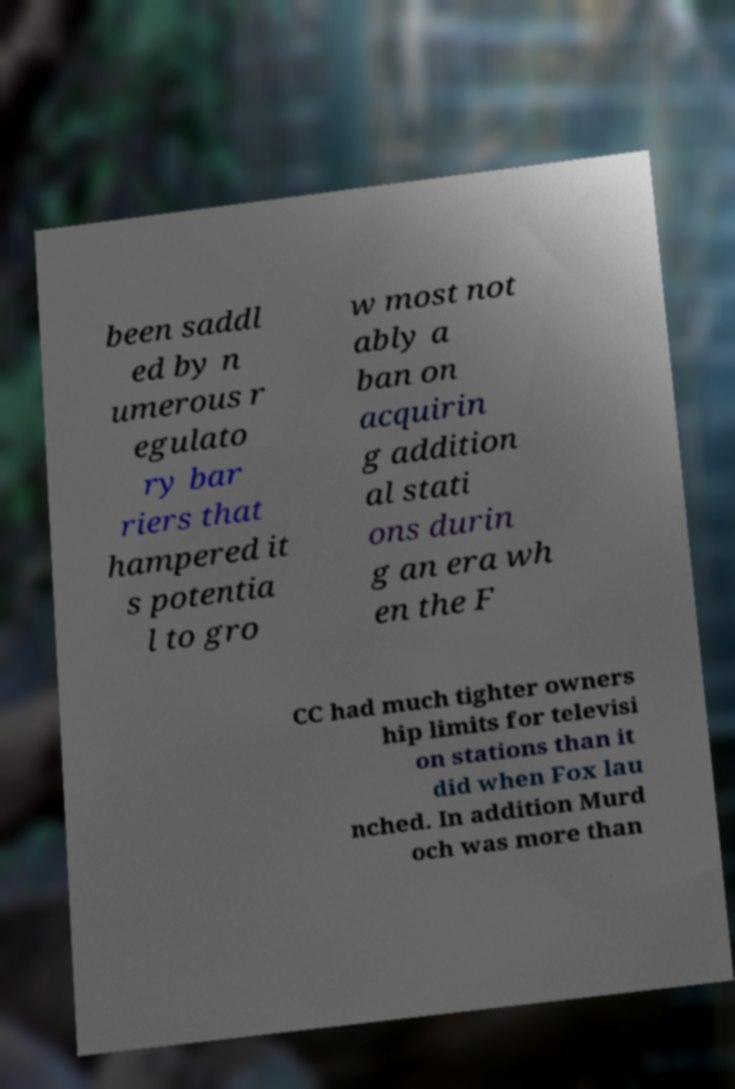What messages or text are displayed in this image? I need them in a readable, typed format. been saddl ed by n umerous r egulato ry bar riers that hampered it s potentia l to gro w most not ably a ban on acquirin g addition al stati ons durin g an era wh en the F CC had much tighter owners hip limits for televisi on stations than it did when Fox lau nched. In addition Murd och was more than 